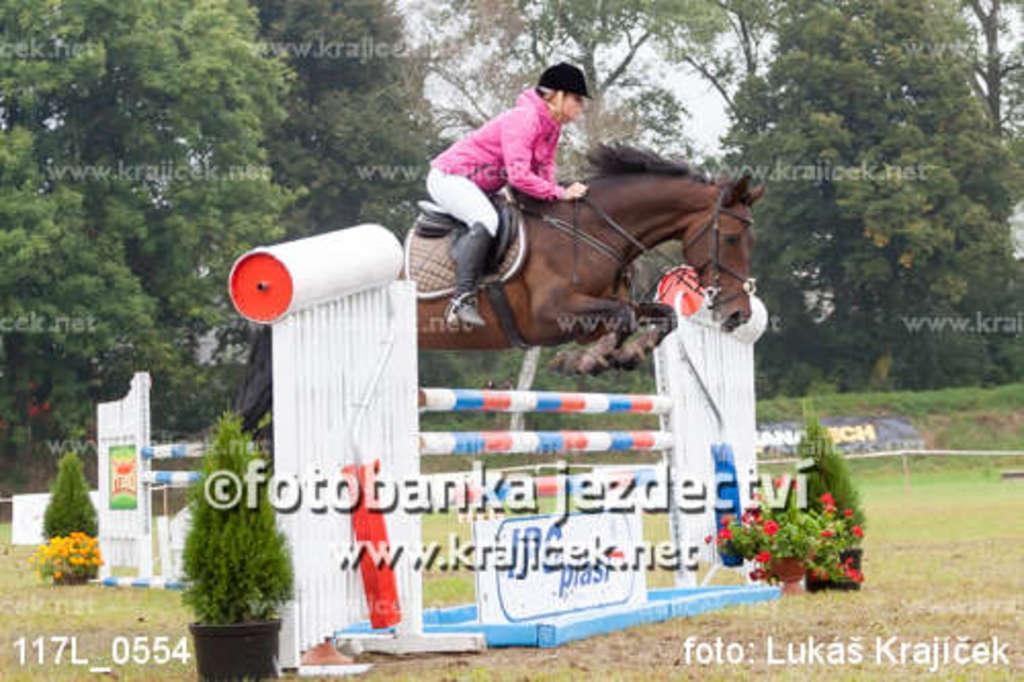What is the person in the image doing? The person is sitting on a horse in the image. What objects are present in the image besides the person and the horse? There are flower pots and plants in the image. What can be seen in the background of the image? There are trees in the background of the image. What type of riddle is the doctor solving in the image? There is no doctor or riddle present in the image; it features a person sitting on a horse with flower pots, plants, and trees in the background. 